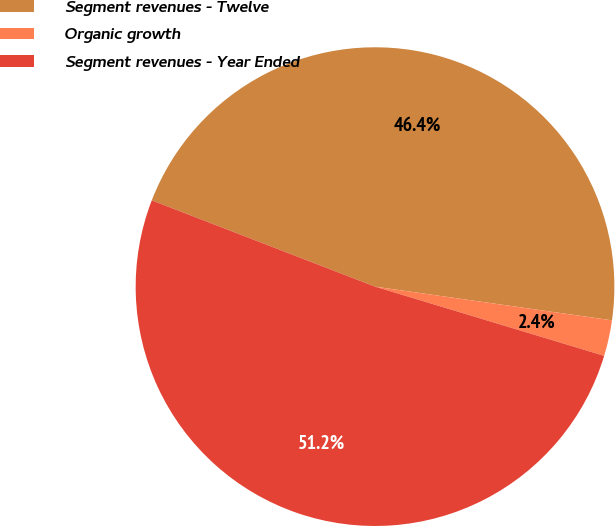Convert chart. <chart><loc_0><loc_0><loc_500><loc_500><pie_chart><fcel>Segment revenues - Twelve<fcel>Organic growth<fcel>Segment revenues - Year Ended<nl><fcel>46.38%<fcel>2.42%<fcel>51.2%<nl></chart> 